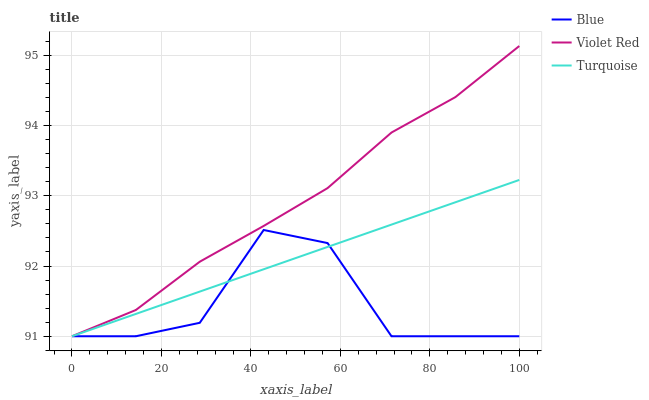Does Blue have the minimum area under the curve?
Answer yes or no. Yes. Does Violet Red have the maximum area under the curve?
Answer yes or no. Yes. Does Turquoise have the minimum area under the curve?
Answer yes or no. No. Does Turquoise have the maximum area under the curve?
Answer yes or no. No. Is Turquoise the smoothest?
Answer yes or no. Yes. Is Blue the roughest?
Answer yes or no. Yes. Is Violet Red the smoothest?
Answer yes or no. No. Is Violet Red the roughest?
Answer yes or no. No. Does Blue have the lowest value?
Answer yes or no. Yes. Does Violet Red have the highest value?
Answer yes or no. Yes. Does Turquoise have the highest value?
Answer yes or no. No. Does Blue intersect Violet Red?
Answer yes or no. Yes. Is Blue less than Violet Red?
Answer yes or no. No. Is Blue greater than Violet Red?
Answer yes or no. No. 